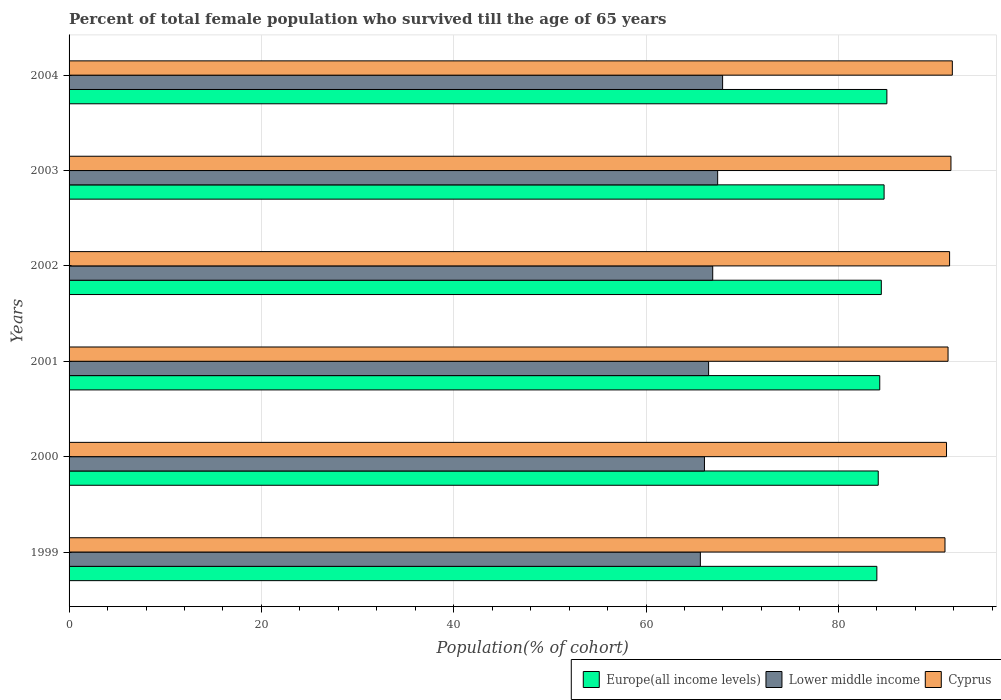How many groups of bars are there?
Ensure brevity in your answer.  6. Are the number of bars per tick equal to the number of legend labels?
Offer a very short reply. Yes. How many bars are there on the 3rd tick from the bottom?
Offer a terse response. 3. What is the percentage of total female population who survived till the age of 65 years in Lower middle income in 2001?
Keep it short and to the point. 66.51. Across all years, what is the maximum percentage of total female population who survived till the age of 65 years in Europe(all income levels)?
Ensure brevity in your answer.  85.05. Across all years, what is the minimum percentage of total female population who survived till the age of 65 years in Europe(all income levels)?
Give a very brief answer. 84. In which year was the percentage of total female population who survived till the age of 65 years in Europe(all income levels) maximum?
Ensure brevity in your answer.  2004. In which year was the percentage of total female population who survived till the age of 65 years in Lower middle income minimum?
Keep it short and to the point. 1999. What is the total percentage of total female population who survived till the age of 65 years in Lower middle income in the graph?
Give a very brief answer. 400.58. What is the difference between the percentage of total female population who survived till the age of 65 years in Cyprus in 1999 and that in 2003?
Provide a succinct answer. -0.62. What is the difference between the percentage of total female population who survived till the age of 65 years in Europe(all income levels) in 2000 and the percentage of total female population who survived till the age of 65 years in Lower middle income in 2002?
Offer a terse response. 17.21. What is the average percentage of total female population who survived till the age of 65 years in Europe(all income levels) per year?
Provide a short and direct response. 84.46. In the year 2003, what is the difference between the percentage of total female population who survived till the age of 65 years in Cyprus and percentage of total female population who survived till the age of 65 years in Lower middle income?
Make the answer very short. 24.26. What is the ratio of the percentage of total female population who survived till the age of 65 years in Lower middle income in 2001 to that in 2004?
Keep it short and to the point. 0.98. Is the difference between the percentage of total female population who survived till the age of 65 years in Cyprus in 1999 and 2000 greater than the difference between the percentage of total female population who survived till the age of 65 years in Lower middle income in 1999 and 2000?
Your answer should be very brief. Yes. What is the difference between the highest and the second highest percentage of total female population who survived till the age of 65 years in Lower middle income?
Provide a short and direct response. 0.51. What is the difference between the highest and the lowest percentage of total female population who survived till the age of 65 years in Lower middle income?
Make the answer very short. 2.31. Is the sum of the percentage of total female population who survived till the age of 65 years in Cyprus in 2001 and 2002 greater than the maximum percentage of total female population who survived till the age of 65 years in Europe(all income levels) across all years?
Provide a short and direct response. Yes. What does the 3rd bar from the top in 2003 represents?
Offer a terse response. Europe(all income levels). What does the 1st bar from the bottom in 2001 represents?
Give a very brief answer. Europe(all income levels). Are all the bars in the graph horizontal?
Your answer should be very brief. Yes. What is the difference between two consecutive major ticks on the X-axis?
Offer a very short reply. 20. Are the values on the major ticks of X-axis written in scientific E-notation?
Keep it short and to the point. No. Does the graph contain any zero values?
Make the answer very short. No. Does the graph contain grids?
Your answer should be compact. Yes. How many legend labels are there?
Offer a very short reply. 3. What is the title of the graph?
Keep it short and to the point. Percent of total female population who survived till the age of 65 years. Does "Poland" appear as one of the legend labels in the graph?
Ensure brevity in your answer.  No. What is the label or title of the X-axis?
Ensure brevity in your answer.  Population(% of cohort). What is the Population(% of cohort) in Europe(all income levels) in 1999?
Your response must be concise. 84. What is the Population(% of cohort) of Lower middle income in 1999?
Make the answer very short. 65.65. What is the Population(% of cohort) of Cyprus in 1999?
Your answer should be very brief. 91.09. What is the Population(% of cohort) in Europe(all income levels) in 2000?
Offer a terse response. 84.15. What is the Population(% of cohort) in Lower middle income in 2000?
Give a very brief answer. 66.08. What is the Population(% of cohort) in Cyprus in 2000?
Provide a short and direct response. 91.25. What is the Population(% of cohort) in Europe(all income levels) in 2001?
Your answer should be compact. 84.31. What is the Population(% of cohort) in Lower middle income in 2001?
Provide a short and direct response. 66.51. What is the Population(% of cohort) of Cyprus in 2001?
Your answer should be very brief. 91.41. What is the Population(% of cohort) of Europe(all income levels) in 2002?
Keep it short and to the point. 84.47. What is the Population(% of cohort) of Lower middle income in 2002?
Ensure brevity in your answer.  66.94. What is the Population(% of cohort) in Cyprus in 2002?
Offer a terse response. 91.57. What is the Population(% of cohort) of Europe(all income levels) in 2003?
Make the answer very short. 84.76. What is the Population(% of cohort) of Lower middle income in 2003?
Provide a short and direct response. 67.45. What is the Population(% of cohort) of Cyprus in 2003?
Make the answer very short. 91.71. What is the Population(% of cohort) in Europe(all income levels) in 2004?
Ensure brevity in your answer.  85.05. What is the Population(% of cohort) of Lower middle income in 2004?
Offer a terse response. 67.96. What is the Population(% of cohort) of Cyprus in 2004?
Give a very brief answer. 91.85. Across all years, what is the maximum Population(% of cohort) of Europe(all income levels)?
Provide a short and direct response. 85.05. Across all years, what is the maximum Population(% of cohort) of Lower middle income?
Make the answer very short. 67.96. Across all years, what is the maximum Population(% of cohort) of Cyprus?
Ensure brevity in your answer.  91.85. Across all years, what is the minimum Population(% of cohort) of Europe(all income levels)?
Give a very brief answer. 84. Across all years, what is the minimum Population(% of cohort) of Lower middle income?
Your answer should be compact. 65.65. Across all years, what is the minimum Population(% of cohort) in Cyprus?
Keep it short and to the point. 91.09. What is the total Population(% of cohort) in Europe(all income levels) in the graph?
Your response must be concise. 506.73. What is the total Population(% of cohort) in Lower middle income in the graph?
Give a very brief answer. 400.58. What is the total Population(% of cohort) in Cyprus in the graph?
Your response must be concise. 548.88. What is the difference between the Population(% of cohort) in Europe(all income levels) in 1999 and that in 2000?
Provide a succinct answer. -0.14. What is the difference between the Population(% of cohort) in Lower middle income in 1999 and that in 2000?
Your answer should be compact. -0.43. What is the difference between the Population(% of cohort) of Cyprus in 1999 and that in 2000?
Your answer should be very brief. -0.16. What is the difference between the Population(% of cohort) of Europe(all income levels) in 1999 and that in 2001?
Ensure brevity in your answer.  -0.3. What is the difference between the Population(% of cohort) in Lower middle income in 1999 and that in 2001?
Make the answer very short. -0.86. What is the difference between the Population(% of cohort) in Cyprus in 1999 and that in 2001?
Provide a short and direct response. -0.32. What is the difference between the Population(% of cohort) in Europe(all income levels) in 1999 and that in 2002?
Provide a short and direct response. -0.46. What is the difference between the Population(% of cohort) of Lower middle income in 1999 and that in 2002?
Give a very brief answer. -1.29. What is the difference between the Population(% of cohort) in Cyprus in 1999 and that in 2002?
Your answer should be compact. -0.48. What is the difference between the Population(% of cohort) in Europe(all income levels) in 1999 and that in 2003?
Offer a terse response. -0.75. What is the difference between the Population(% of cohort) in Lower middle income in 1999 and that in 2003?
Provide a short and direct response. -1.8. What is the difference between the Population(% of cohort) in Cyprus in 1999 and that in 2003?
Offer a very short reply. -0.62. What is the difference between the Population(% of cohort) of Europe(all income levels) in 1999 and that in 2004?
Give a very brief answer. -1.04. What is the difference between the Population(% of cohort) in Lower middle income in 1999 and that in 2004?
Offer a terse response. -2.31. What is the difference between the Population(% of cohort) of Cyprus in 1999 and that in 2004?
Your answer should be compact. -0.76. What is the difference between the Population(% of cohort) of Europe(all income levels) in 2000 and that in 2001?
Give a very brief answer. -0.16. What is the difference between the Population(% of cohort) of Lower middle income in 2000 and that in 2001?
Make the answer very short. -0.43. What is the difference between the Population(% of cohort) of Cyprus in 2000 and that in 2001?
Your response must be concise. -0.16. What is the difference between the Population(% of cohort) of Europe(all income levels) in 2000 and that in 2002?
Offer a very short reply. -0.32. What is the difference between the Population(% of cohort) in Lower middle income in 2000 and that in 2002?
Your response must be concise. -0.86. What is the difference between the Population(% of cohort) of Cyprus in 2000 and that in 2002?
Offer a very short reply. -0.32. What is the difference between the Population(% of cohort) of Europe(all income levels) in 2000 and that in 2003?
Offer a terse response. -0.61. What is the difference between the Population(% of cohort) in Lower middle income in 2000 and that in 2003?
Your response must be concise. -1.37. What is the difference between the Population(% of cohort) of Cyprus in 2000 and that in 2003?
Ensure brevity in your answer.  -0.46. What is the difference between the Population(% of cohort) in Europe(all income levels) in 2000 and that in 2004?
Ensure brevity in your answer.  -0.9. What is the difference between the Population(% of cohort) in Lower middle income in 2000 and that in 2004?
Your response must be concise. -1.89. What is the difference between the Population(% of cohort) of Cyprus in 2000 and that in 2004?
Provide a short and direct response. -0.6. What is the difference between the Population(% of cohort) of Europe(all income levels) in 2001 and that in 2002?
Your answer should be compact. -0.16. What is the difference between the Population(% of cohort) in Lower middle income in 2001 and that in 2002?
Your response must be concise. -0.43. What is the difference between the Population(% of cohort) of Cyprus in 2001 and that in 2002?
Your answer should be very brief. -0.16. What is the difference between the Population(% of cohort) in Europe(all income levels) in 2001 and that in 2003?
Keep it short and to the point. -0.45. What is the difference between the Population(% of cohort) of Lower middle income in 2001 and that in 2003?
Ensure brevity in your answer.  -0.94. What is the difference between the Population(% of cohort) of Cyprus in 2001 and that in 2003?
Keep it short and to the point. -0.3. What is the difference between the Population(% of cohort) of Europe(all income levels) in 2001 and that in 2004?
Your response must be concise. -0.74. What is the difference between the Population(% of cohort) of Lower middle income in 2001 and that in 2004?
Your answer should be compact. -1.46. What is the difference between the Population(% of cohort) in Cyprus in 2001 and that in 2004?
Give a very brief answer. -0.44. What is the difference between the Population(% of cohort) of Europe(all income levels) in 2002 and that in 2003?
Offer a very short reply. -0.29. What is the difference between the Population(% of cohort) of Lower middle income in 2002 and that in 2003?
Your response must be concise. -0.51. What is the difference between the Population(% of cohort) in Cyprus in 2002 and that in 2003?
Make the answer very short. -0.14. What is the difference between the Population(% of cohort) of Europe(all income levels) in 2002 and that in 2004?
Your answer should be very brief. -0.58. What is the difference between the Population(% of cohort) of Lower middle income in 2002 and that in 2004?
Your response must be concise. -1.03. What is the difference between the Population(% of cohort) in Cyprus in 2002 and that in 2004?
Make the answer very short. -0.28. What is the difference between the Population(% of cohort) of Europe(all income levels) in 2003 and that in 2004?
Ensure brevity in your answer.  -0.29. What is the difference between the Population(% of cohort) in Lower middle income in 2003 and that in 2004?
Give a very brief answer. -0.51. What is the difference between the Population(% of cohort) in Cyprus in 2003 and that in 2004?
Keep it short and to the point. -0.14. What is the difference between the Population(% of cohort) in Europe(all income levels) in 1999 and the Population(% of cohort) in Lower middle income in 2000?
Give a very brief answer. 17.93. What is the difference between the Population(% of cohort) of Europe(all income levels) in 1999 and the Population(% of cohort) of Cyprus in 2000?
Give a very brief answer. -7.24. What is the difference between the Population(% of cohort) in Lower middle income in 1999 and the Population(% of cohort) in Cyprus in 2000?
Your answer should be very brief. -25.6. What is the difference between the Population(% of cohort) of Europe(all income levels) in 1999 and the Population(% of cohort) of Lower middle income in 2001?
Give a very brief answer. 17.5. What is the difference between the Population(% of cohort) in Europe(all income levels) in 1999 and the Population(% of cohort) in Cyprus in 2001?
Give a very brief answer. -7.4. What is the difference between the Population(% of cohort) in Lower middle income in 1999 and the Population(% of cohort) in Cyprus in 2001?
Your response must be concise. -25.76. What is the difference between the Population(% of cohort) in Europe(all income levels) in 1999 and the Population(% of cohort) in Lower middle income in 2002?
Give a very brief answer. 17.07. What is the difference between the Population(% of cohort) of Europe(all income levels) in 1999 and the Population(% of cohort) of Cyprus in 2002?
Give a very brief answer. -7.56. What is the difference between the Population(% of cohort) of Lower middle income in 1999 and the Population(% of cohort) of Cyprus in 2002?
Give a very brief answer. -25.92. What is the difference between the Population(% of cohort) in Europe(all income levels) in 1999 and the Population(% of cohort) in Lower middle income in 2003?
Your answer should be compact. 16.56. What is the difference between the Population(% of cohort) of Europe(all income levels) in 1999 and the Population(% of cohort) of Cyprus in 2003?
Provide a succinct answer. -7.71. What is the difference between the Population(% of cohort) in Lower middle income in 1999 and the Population(% of cohort) in Cyprus in 2003?
Offer a very short reply. -26.06. What is the difference between the Population(% of cohort) of Europe(all income levels) in 1999 and the Population(% of cohort) of Lower middle income in 2004?
Your answer should be compact. 16.04. What is the difference between the Population(% of cohort) in Europe(all income levels) in 1999 and the Population(% of cohort) in Cyprus in 2004?
Make the answer very short. -7.85. What is the difference between the Population(% of cohort) of Lower middle income in 1999 and the Population(% of cohort) of Cyprus in 2004?
Provide a short and direct response. -26.2. What is the difference between the Population(% of cohort) in Europe(all income levels) in 2000 and the Population(% of cohort) in Lower middle income in 2001?
Ensure brevity in your answer.  17.64. What is the difference between the Population(% of cohort) in Europe(all income levels) in 2000 and the Population(% of cohort) in Cyprus in 2001?
Ensure brevity in your answer.  -7.26. What is the difference between the Population(% of cohort) of Lower middle income in 2000 and the Population(% of cohort) of Cyprus in 2001?
Ensure brevity in your answer.  -25.33. What is the difference between the Population(% of cohort) in Europe(all income levels) in 2000 and the Population(% of cohort) in Lower middle income in 2002?
Provide a succinct answer. 17.21. What is the difference between the Population(% of cohort) of Europe(all income levels) in 2000 and the Population(% of cohort) of Cyprus in 2002?
Provide a short and direct response. -7.42. What is the difference between the Population(% of cohort) of Lower middle income in 2000 and the Population(% of cohort) of Cyprus in 2002?
Provide a short and direct response. -25.49. What is the difference between the Population(% of cohort) in Europe(all income levels) in 2000 and the Population(% of cohort) in Lower middle income in 2003?
Offer a terse response. 16.7. What is the difference between the Population(% of cohort) in Europe(all income levels) in 2000 and the Population(% of cohort) in Cyprus in 2003?
Make the answer very short. -7.56. What is the difference between the Population(% of cohort) of Lower middle income in 2000 and the Population(% of cohort) of Cyprus in 2003?
Your response must be concise. -25.63. What is the difference between the Population(% of cohort) in Europe(all income levels) in 2000 and the Population(% of cohort) in Lower middle income in 2004?
Your response must be concise. 16.18. What is the difference between the Population(% of cohort) of Europe(all income levels) in 2000 and the Population(% of cohort) of Cyprus in 2004?
Offer a very short reply. -7.71. What is the difference between the Population(% of cohort) in Lower middle income in 2000 and the Population(% of cohort) in Cyprus in 2004?
Give a very brief answer. -25.78. What is the difference between the Population(% of cohort) of Europe(all income levels) in 2001 and the Population(% of cohort) of Lower middle income in 2002?
Your response must be concise. 17.37. What is the difference between the Population(% of cohort) of Europe(all income levels) in 2001 and the Population(% of cohort) of Cyprus in 2002?
Provide a succinct answer. -7.26. What is the difference between the Population(% of cohort) of Lower middle income in 2001 and the Population(% of cohort) of Cyprus in 2002?
Offer a terse response. -25.06. What is the difference between the Population(% of cohort) in Europe(all income levels) in 2001 and the Population(% of cohort) in Lower middle income in 2003?
Your answer should be compact. 16.86. What is the difference between the Population(% of cohort) in Europe(all income levels) in 2001 and the Population(% of cohort) in Cyprus in 2003?
Give a very brief answer. -7.41. What is the difference between the Population(% of cohort) in Lower middle income in 2001 and the Population(% of cohort) in Cyprus in 2003?
Make the answer very short. -25.2. What is the difference between the Population(% of cohort) of Europe(all income levels) in 2001 and the Population(% of cohort) of Lower middle income in 2004?
Provide a short and direct response. 16.34. What is the difference between the Population(% of cohort) in Europe(all income levels) in 2001 and the Population(% of cohort) in Cyprus in 2004?
Give a very brief answer. -7.55. What is the difference between the Population(% of cohort) of Lower middle income in 2001 and the Population(% of cohort) of Cyprus in 2004?
Provide a short and direct response. -25.35. What is the difference between the Population(% of cohort) of Europe(all income levels) in 2002 and the Population(% of cohort) of Lower middle income in 2003?
Keep it short and to the point. 17.02. What is the difference between the Population(% of cohort) of Europe(all income levels) in 2002 and the Population(% of cohort) of Cyprus in 2003?
Ensure brevity in your answer.  -7.24. What is the difference between the Population(% of cohort) in Lower middle income in 2002 and the Population(% of cohort) in Cyprus in 2003?
Ensure brevity in your answer.  -24.77. What is the difference between the Population(% of cohort) in Europe(all income levels) in 2002 and the Population(% of cohort) in Lower middle income in 2004?
Offer a terse response. 16.5. What is the difference between the Population(% of cohort) in Europe(all income levels) in 2002 and the Population(% of cohort) in Cyprus in 2004?
Your answer should be compact. -7.39. What is the difference between the Population(% of cohort) of Lower middle income in 2002 and the Population(% of cohort) of Cyprus in 2004?
Your answer should be very brief. -24.92. What is the difference between the Population(% of cohort) in Europe(all income levels) in 2003 and the Population(% of cohort) in Lower middle income in 2004?
Make the answer very short. 16.79. What is the difference between the Population(% of cohort) of Europe(all income levels) in 2003 and the Population(% of cohort) of Cyprus in 2004?
Ensure brevity in your answer.  -7.1. What is the difference between the Population(% of cohort) of Lower middle income in 2003 and the Population(% of cohort) of Cyprus in 2004?
Keep it short and to the point. -24.4. What is the average Population(% of cohort) in Europe(all income levels) per year?
Make the answer very short. 84.46. What is the average Population(% of cohort) in Lower middle income per year?
Your answer should be compact. 66.76. What is the average Population(% of cohort) in Cyprus per year?
Make the answer very short. 91.48. In the year 1999, what is the difference between the Population(% of cohort) of Europe(all income levels) and Population(% of cohort) of Lower middle income?
Give a very brief answer. 18.36. In the year 1999, what is the difference between the Population(% of cohort) in Europe(all income levels) and Population(% of cohort) in Cyprus?
Your response must be concise. -7.08. In the year 1999, what is the difference between the Population(% of cohort) in Lower middle income and Population(% of cohort) in Cyprus?
Your answer should be compact. -25.44. In the year 2000, what is the difference between the Population(% of cohort) of Europe(all income levels) and Population(% of cohort) of Lower middle income?
Keep it short and to the point. 18.07. In the year 2000, what is the difference between the Population(% of cohort) in Europe(all income levels) and Population(% of cohort) in Cyprus?
Provide a succinct answer. -7.1. In the year 2000, what is the difference between the Population(% of cohort) in Lower middle income and Population(% of cohort) in Cyprus?
Keep it short and to the point. -25.17. In the year 2001, what is the difference between the Population(% of cohort) in Europe(all income levels) and Population(% of cohort) in Lower middle income?
Offer a terse response. 17.8. In the year 2001, what is the difference between the Population(% of cohort) of Europe(all income levels) and Population(% of cohort) of Cyprus?
Your answer should be very brief. -7.1. In the year 2001, what is the difference between the Population(% of cohort) of Lower middle income and Population(% of cohort) of Cyprus?
Offer a very short reply. -24.9. In the year 2002, what is the difference between the Population(% of cohort) of Europe(all income levels) and Population(% of cohort) of Lower middle income?
Your answer should be compact. 17.53. In the year 2002, what is the difference between the Population(% of cohort) in Europe(all income levels) and Population(% of cohort) in Cyprus?
Make the answer very short. -7.1. In the year 2002, what is the difference between the Population(% of cohort) of Lower middle income and Population(% of cohort) of Cyprus?
Your answer should be compact. -24.63. In the year 2003, what is the difference between the Population(% of cohort) in Europe(all income levels) and Population(% of cohort) in Lower middle income?
Make the answer very short. 17.31. In the year 2003, what is the difference between the Population(% of cohort) in Europe(all income levels) and Population(% of cohort) in Cyprus?
Provide a short and direct response. -6.95. In the year 2003, what is the difference between the Population(% of cohort) of Lower middle income and Population(% of cohort) of Cyprus?
Provide a succinct answer. -24.26. In the year 2004, what is the difference between the Population(% of cohort) in Europe(all income levels) and Population(% of cohort) in Lower middle income?
Offer a terse response. 17.08. In the year 2004, what is the difference between the Population(% of cohort) of Europe(all income levels) and Population(% of cohort) of Cyprus?
Your response must be concise. -6.81. In the year 2004, what is the difference between the Population(% of cohort) in Lower middle income and Population(% of cohort) in Cyprus?
Provide a succinct answer. -23.89. What is the ratio of the Population(% of cohort) of Cyprus in 1999 to that in 2000?
Your answer should be compact. 1. What is the ratio of the Population(% of cohort) in Lower middle income in 1999 to that in 2001?
Provide a short and direct response. 0.99. What is the ratio of the Population(% of cohort) in Cyprus in 1999 to that in 2001?
Your answer should be compact. 1. What is the ratio of the Population(% of cohort) of Europe(all income levels) in 1999 to that in 2002?
Provide a succinct answer. 0.99. What is the ratio of the Population(% of cohort) of Lower middle income in 1999 to that in 2002?
Make the answer very short. 0.98. What is the ratio of the Population(% of cohort) of Lower middle income in 1999 to that in 2003?
Keep it short and to the point. 0.97. What is the ratio of the Population(% of cohort) of Europe(all income levels) in 1999 to that in 2004?
Offer a very short reply. 0.99. What is the ratio of the Population(% of cohort) of Lower middle income in 1999 to that in 2004?
Your answer should be very brief. 0.97. What is the ratio of the Population(% of cohort) of Europe(all income levels) in 2000 to that in 2001?
Provide a succinct answer. 1. What is the ratio of the Population(% of cohort) of Lower middle income in 2000 to that in 2001?
Ensure brevity in your answer.  0.99. What is the ratio of the Population(% of cohort) of Lower middle income in 2000 to that in 2002?
Your answer should be very brief. 0.99. What is the ratio of the Population(% of cohort) in Lower middle income in 2000 to that in 2003?
Provide a succinct answer. 0.98. What is the ratio of the Population(% of cohort) in Cyprus in 2000 to that in 2003?
Ensure brevity in your answer.  0.99. What is the ratio of the Population(% of cohort) in Lower middle income in 2000 to that in 2004?
Ensure brevity in your answer.  0.97. What is the ratio of the Population(% of cohort) in Cyprus in 2000 to that in 2004?
Provide a short and direct response. 0.99. What is the ratio of the Population(% of cohort) in Lower middle income in 2001 to that in 2002?
Offer a terse response. 0.99. What is the ratio of the Population(% of cohort) of Cyprus in 2001 to that in 2002?
Provide a short and direct response. 1. What is the ratio of the Population(% of cohort) in Europe(all income levels) in 2001 to that in 2003?
Your answer should be very brief. 0.99. What is the ratio of the Population(% of cohort) in Lower middle income in 2001 to that in 2003?
Your answer should be very brief. 0.99. What is the ratio of the Population(% of cohort) in Europe(all income levels) in 2001 to that in 2004?
Your response must be concise. 0.99. What is the ratio of the Population(% of cohort) of Lower middle income in 2001 to that in 2004?
Offer a very short reply. 0.98. What is the ratio of the Population(% of cohort) in Cyprus in 2001 to that in 2004?
Your answer should be very brief. 1. What is the ratio of the Population(% of cohort) of Lower middle income in 2002 to that in 2003?
Your answer should be very brief. 0.99. What is the ratio of the Population(% of cohort) of Lower middle income in 2002 to that in 2004?
Provide a succinct answer. 0.98. What is the ratio of the Population(% of cohort) of Cyprus in 2002 to that in 2004?
Provide a short and direct response. 1. What is the ratio of the Population(% of cohort) of Europe(all income levels) in 2003 to that in 2004?
Your answer should be very brief. 1. What is the ratio of the Population(% of cohort) in Lower middle income in 2003 to that in 2004?
Provide a short and direct response. 0.99. What is the difference between the highest and the second highest Population(% of cohort) in Europe(all income levels)?
Your answer should be compact. 0.29. What is the difference between the highest and the second highest Population(% of cohort) of Lower middle income?
Your response must be concise. 0.51. What is the difference between the highest and the second highest Population(% of cohort) of Cyprus?
Provide a short and direct response. 0.14. What is the difference between the highest and the lowest Population(% of cohort) of Europe(all income levels)?
Provide a short and direct response. 1.04. What is the difference between the highest and the lowest Population(% of cohort) of Lower middle income?
Offer a very short reply. 2.31. What is the difference between the highest and the lowest Population(% of cohort) in Cyprus?
Offer a terse response. 0.76. 